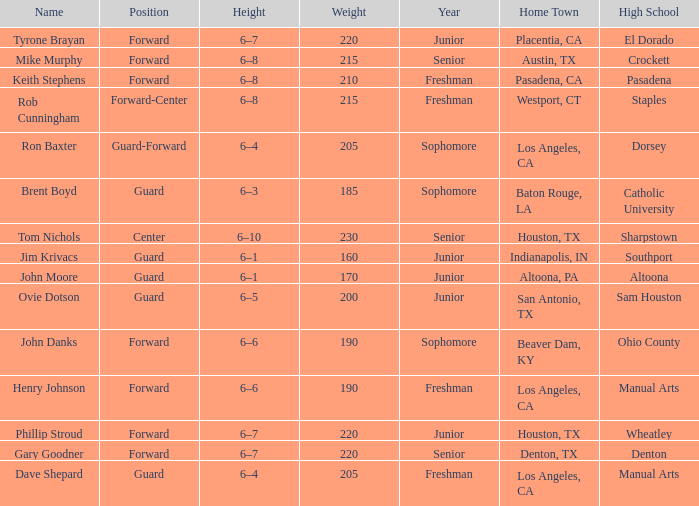What is the Position with a Year with freshman, and a Weight larger than 210? Forward-Center. 